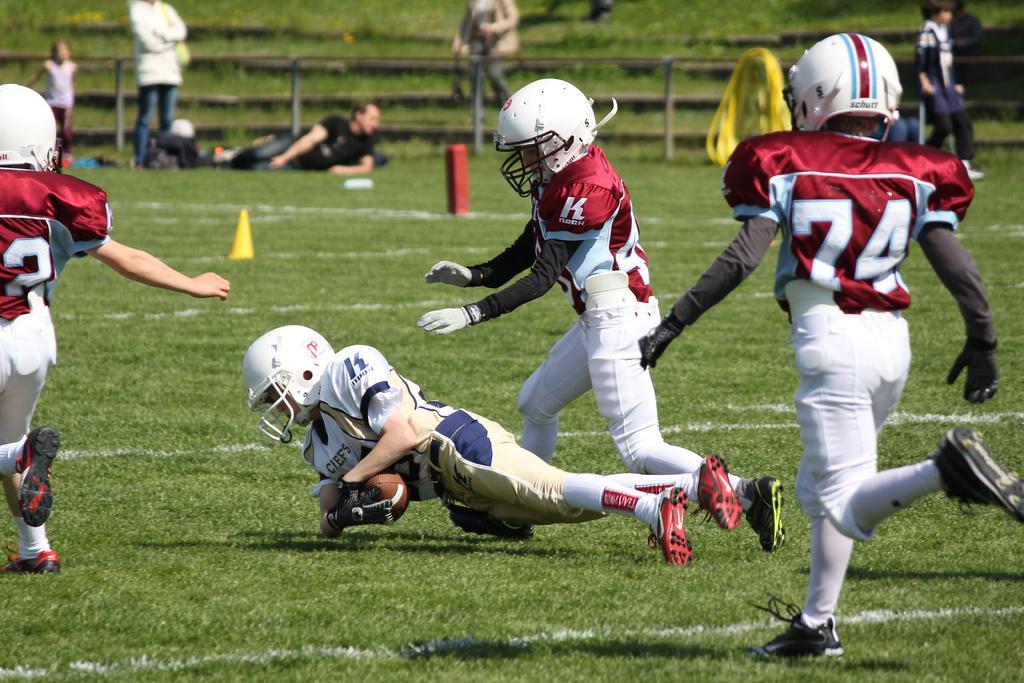Can you describe this image briefly? This is a picture taken in the outdoors. It is sunny. On the ground there are kids playing the american football. Behind the people there is a fencing and some yellow color item and man in black t shirt was lying on the floor. 